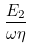Convert formula to latex. <formula><loc_0><loc_0><loc_500><loc_500>\frac { E _ { 2 } } { \omega \eta }</formula> 